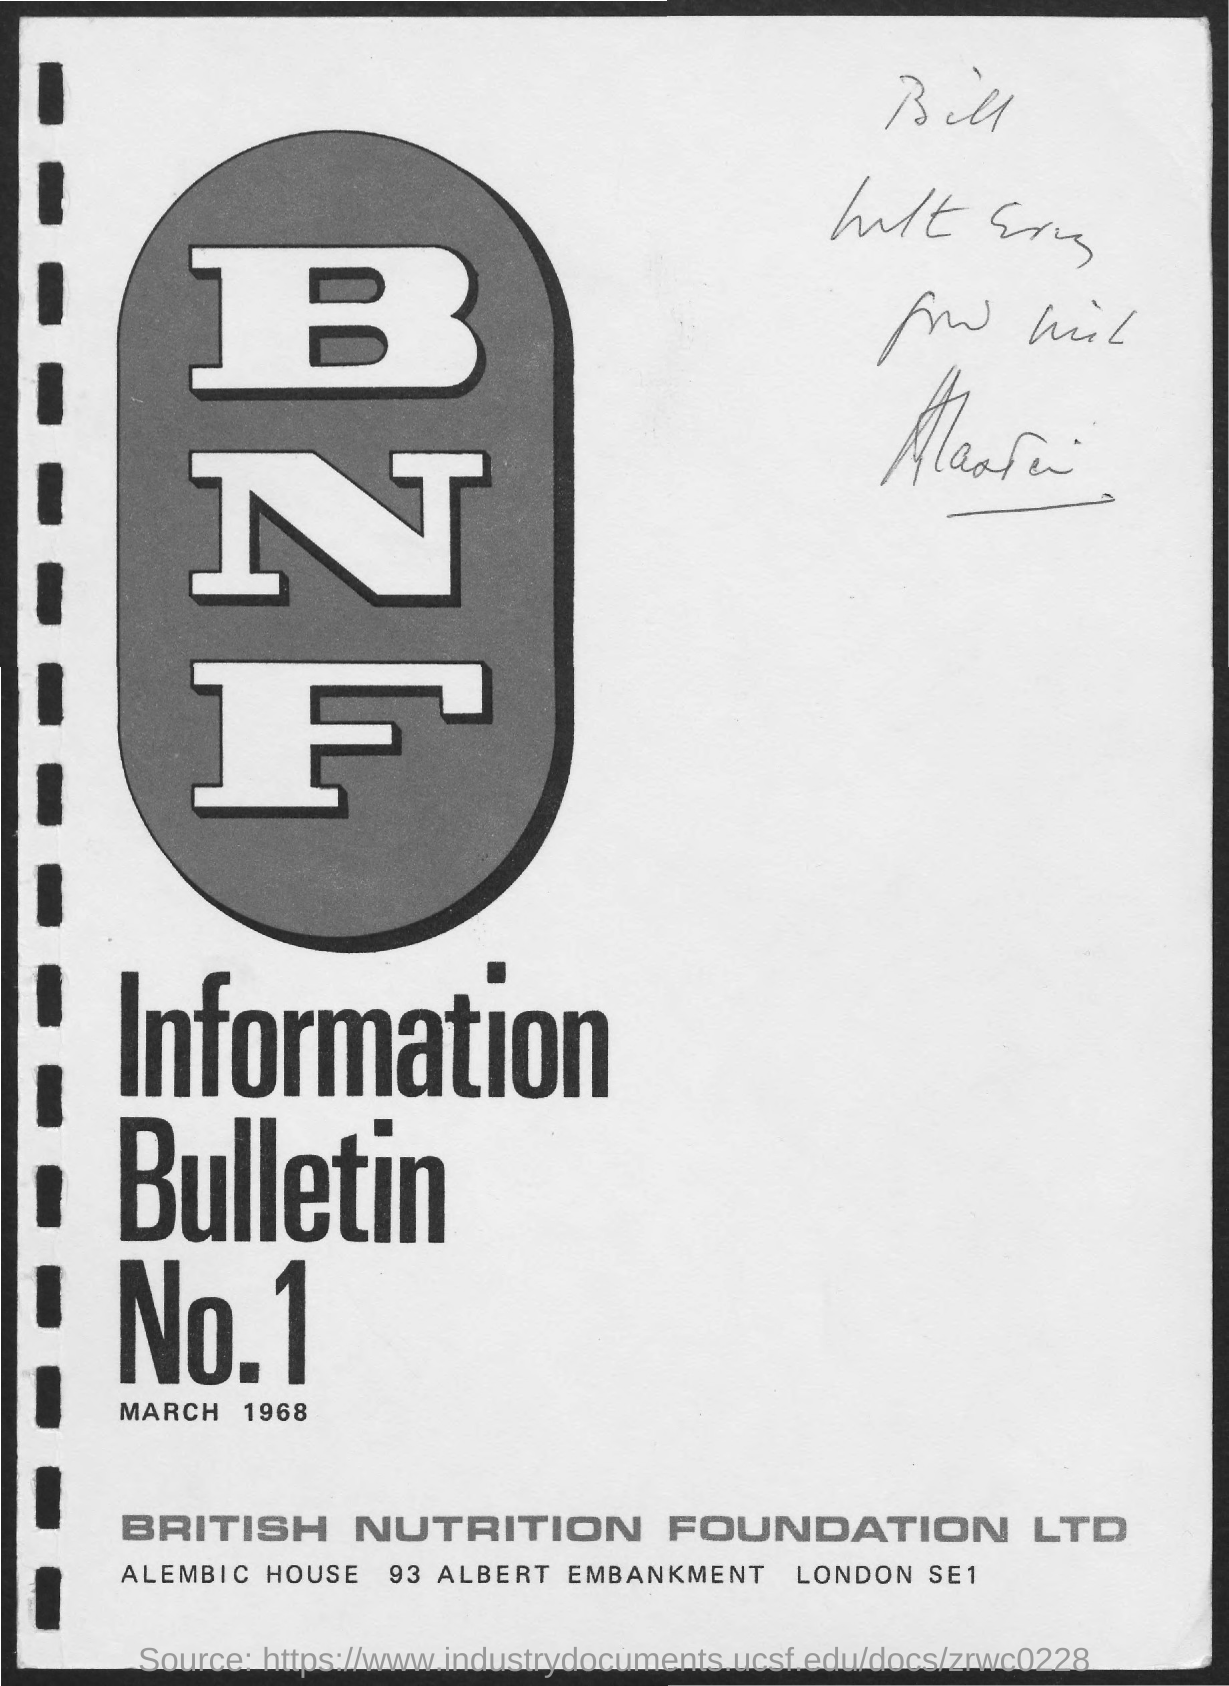What is the date mentioned in the document?
Provide a succinct answer. MARCH 1968. 